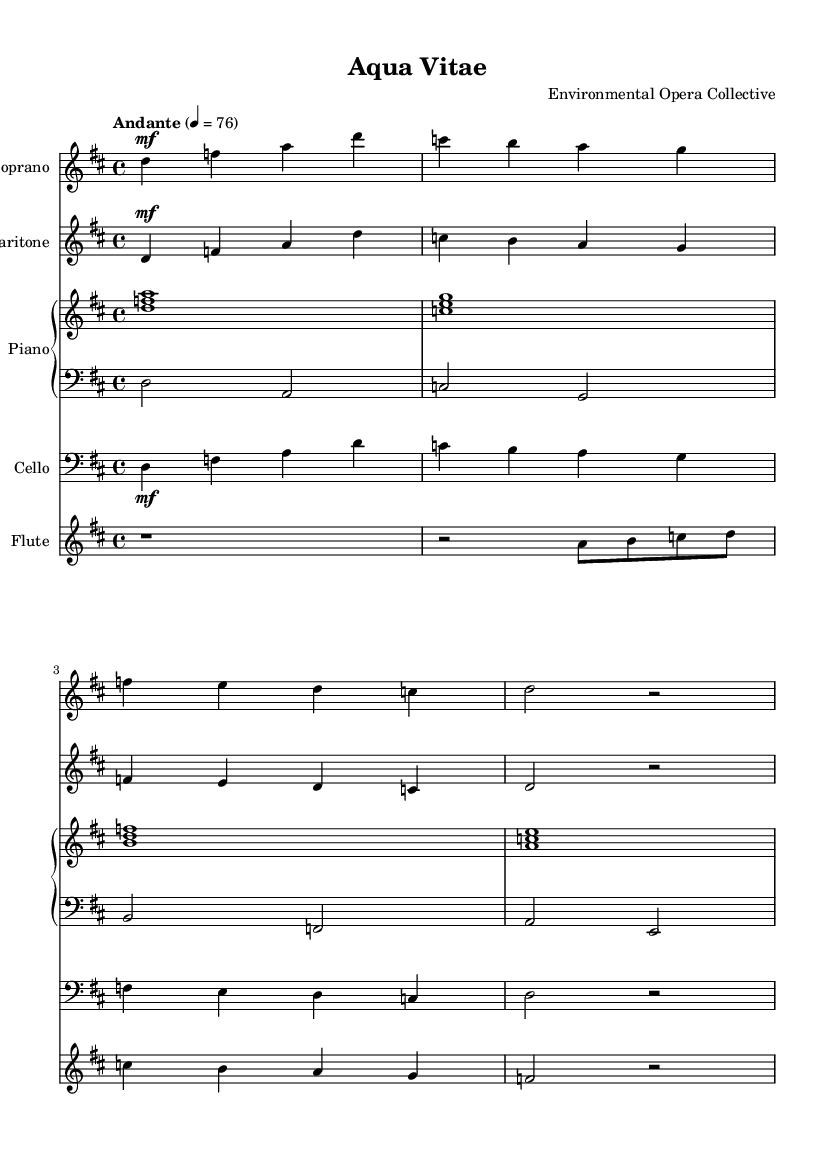What is the key signature of this music? The key signature is indicated at the beginning of the score. In this piece, it shows two sharps, which corresponds to the D major key.
Answer: D major What is the time signature of the music? The time signature is displayed at the beginning of the score right after the key signature. Here, it is 4/4, indicating that there are four beats in each measure.
Answer: 4/4 What is the tempo marking for this piece? The tempo marking is provided at the beginning of the score, stating "Andante" with a metronome mark of 76. This indicates a moderately slow pace for the music.
Answer: Andante 76 How many measures are in the soprano part? To find the number of measures, we can count the distinct sets of notes between the vertical bar lines in the soprano part. There are four measures present in the soprano section.
Answer: Four Which instruments are involved in this opera score? The instruments are listed in the score under each staff. The specific instruments present include Soprano, Baritone, Piano (with both upper and lower staves), Cello, and Flute.
Answer: Soprano, Baritone, Piano, Cello, Flute What is the primary theme explored in this operatic piece? The title and lyrics indicate that this piece explores themes related to environmental conservation and sustainable living. The use of phrases related to nurturing the earth suggests a focus on ecological themes.
Answer: Environmental conservation What dynamics are indicated for the cello part? The dynamics are specified within the score, directly above the notes in the cello section. The marking is "mf," indicating that the cello should be played at a mezzo forte dynamic level.
Answer: mf 